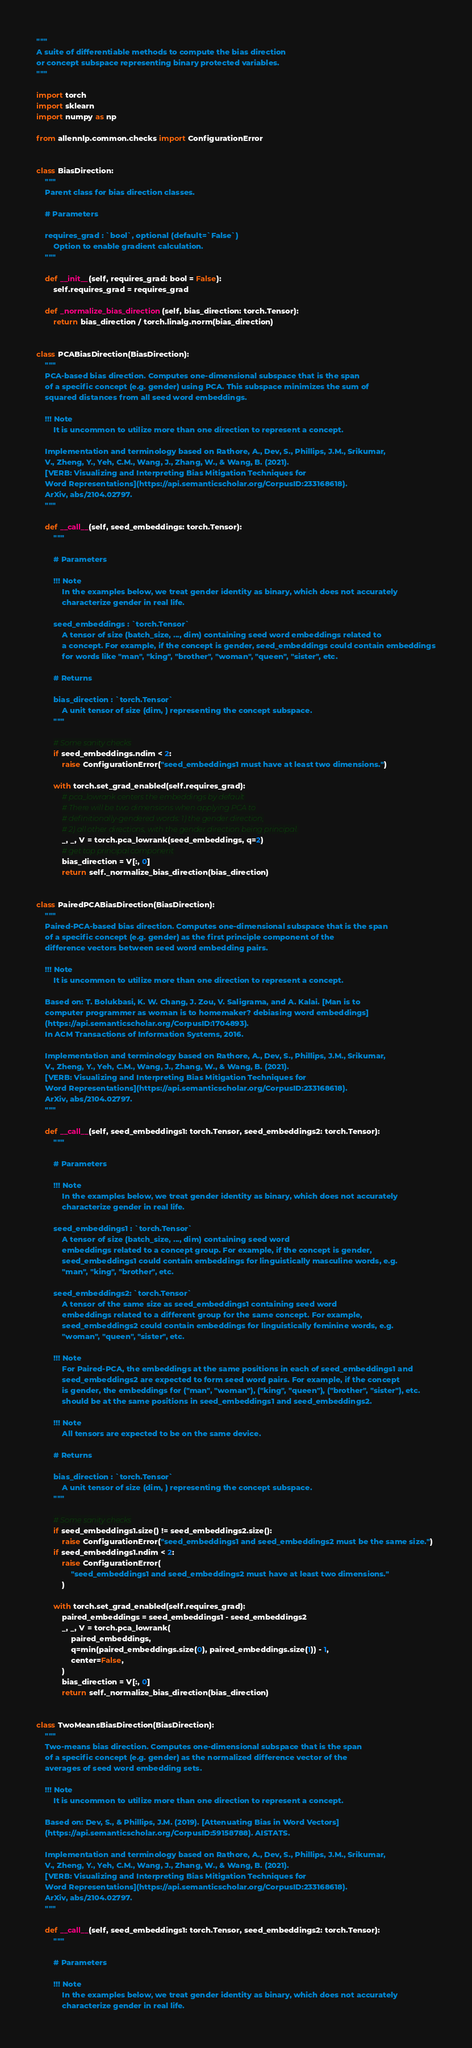<code> <loc_0><loc_0><loc_500><loc_500><_Python_>"""
A suite of differentiable methods to compute the bias direction
or concept subspace representing binary protected variables.
"""

import torch
import sklearn
import numpy as np

from allennlp.common.checks import ConfigurationError


class BiasDirection:
    """
    Parent class for bias direction classes.

    # Parameters

    requires_grad : `bool`, optional (default=`False`)
        Option to enable gradient calculation.
    """

    def __init__(self, requires_grad: bool = False):
        self.requires_grad = requires_grad

    def _normalize_bias_direction(self, bias_direction: torch.Tensor):
        return bias_direction / torch.linalg.norm(bias_direction)


class PCABiasDirection(BiasDirection):
    """
    PCA-based bias direction. Computes one-dimensional subspace that is the span
    of a specific concept (e.g. gender) using PCA. This subspace minimizes the sum of
    squared distances from all seed word embeddings.

    !!! Note
        It is uncommon to utilize more than one direction to represent a concept.

    Implementation and terminology based on Rathore, A., Dev, S., Phillips, J.M., Srikumar,
    V., Zheng, Y., Yeh, C.M., Wang, J., Zhang, W., & Wang, B. (2021).
    [VERB: Visualizing and Interpreting Bias Mitigation Techniques for
    Word Representations](https://api.semanticscholar.org/CorpusID:233168618).
    ArXiv, abs/2104.02797.
    """

    def __call__(self, seed_embeddings: torch.Tensor):
        """

        # Parameters

        !!! Note
            In the examples below, we treat gender identity as binary, which does not accurately
            characterize gender in real life.

        seed_embeddings : `torch.Tensor`
            A tensor of size (batch_size, ..., dim) containing seed word embeddings related to
            a concept. For example, if the concept is gender, seed_embeddings could contain embeddings
            for words like "man", "king", "brother", "woman", "queen", "sister", etc.

        # Returns

        bias_direction : `torch.Tensor`
            A unit tensor of size (dim, ) representing the concept subspace.
        """

        # Some sanity checks
        if seed_embeddings.ndim < 2:
            raise ConfigurationError("seed_embeddings1 must have at least two dimensions.")

        with torch.set_grad_enabled(self.requires_grad):
            # pca_lowrank centers the embeddings by default
            # There will be two dimensions when applying PCA to
            # definitionally-gendered words: 1) the gender direction,
            # 2) all other directions, with the gender direction being principal.
            _, _, V = torch.pca_lowrank(seed_embeddings, q=2)
            # get top principal component
            bias_direction = V[:, 0]
            return self._normalize_bias_direction(bias_direction)


class PairedPCABiasDirection(BiasDirection):
    """
    Paired-PCA-based bias direction. Computes one-dimensional subspace that is the span
    of a specific concept (e.g. gender) as the first principle component of the
    difference vectors between seed word embedding pairs.

    !!! Note
        It is uncommon to utilize more than one direction to represent a concept.

    Based on: T. Bolukbasi, K. W. Chang, J. Zou, V. Saligrama, and A. Kalai. [Man is to
    computer programmer as woman is to homemaker? debiasing word embeddings]
    (https://api.semanticscholar.org/CorpusID:1704893).
    In ACM Transactions of Information Systems, 2016.

    Implementation and terminology based on Rathore, A., Dev, S., Phillips, J.M., Srikumar,
    V., Zheng, Y., Yeh, C.M., Wang, J., Zhang, W., & Wang, B. (2021).
    [VERB: Visualizing and Interpreting Bias Mitigation Techniques for
    Word Representations](https://api.semanticscholar.org/CorpusID:233168618).
    ArXiv, abs/2104.02797.
    """

    def __call__(self, seed_embeddings1: torch.Tensor, seed_embeddings2: torch.Tensor):
        """

        # Parameters

        !!! Note
            In the examples below, we treat gender identity as binary, which does not accurately
            characterize gender in real life.

        seed_embeddings1 : `torch.Tensor`
            A tensor of size (batch_size, ..., dim) containing seed word
            embeddings related to a concept group. For example, if the concept is gender,
            seed_embeddings1 could contain embeddings for linguistically masculine words, e.g.
            "man", "king", "brother", etc.

        seed_embeddings2: `torch.Tensor`
            A tensor of the same size as seed_embeddings1 containing seed word
            embeddings related to a different group for the same concept. For example,
            seed_embeddings2 could contain embeddings for linguistically feminine words, e.g.
            "woman", "queen", "sister", etc.

        !!! Note
            For Paired-PCA, the embeddings at the same positions in each of seed_embeddings1 and
            seed_embeddings2 are expected to form seed word pairs. For example, if the concept
            is gender, the embeddings for ("man", "woman"), ("king", "queen"), ("brother", "sister"), etc.
            should be at the same positions in seed_embeddings1 and seed_embeddings2.

        !!! Note
            All tensors are expected to be on the same device.

        # Returns

        bias_direction : `torch.Tensor`
            A unit tensor of size (dim, ) representing the concept subspace.
        """

        # Some sanity checks
        if seed_embeddings1.size() != seed_embeddings2.size():
            raise ConfigurationError("seed_embeddings1 and seed_embeddings2 must be the same size.")
        if seed_embeddings1.ndim < 2:
            raise ConfigurationError(
                "seed_embeddings1 and seed_embeddings2 must have at least two dimensions."
            )

        with torch.set_grad_enabled(self.requires_grad):
            paired_embeddings = seed_embeddings1 - seed_embeddings2
            _, _, V = torch.pca_lowrank(
                paired_embeddings,
                q=min(paired_embeddings.size(0), paired_embeddings.size(1)) - 1,
                center=False,
            )
            bias_direction = V[:, 0]
            return self._normalize_bias_direction(bias_direction)


class TwoMeansBiasDirection(BiasDirection):
    """
    Two-means bias direction. Computes one-dimensional subspace that is the span
    of a specific concept (e.g. gender) as the normalized difference vector of the
    averages of seed word embedding sets.

    !!! Note
        It is uncommon to utilize more than one direction to represent a concept.

    Based on: Dev, S., & Phillips, J.M. (2019). [Attenuating Bias in Word Vectors]
    (https://api.semanticscholar.org/CorpusID:59158788). AISTATS.

    Implementation and terminology based on Rathore, A., Dev, S., Phillips, J.M., Srikumar,
    V., Zheng, Y., Yeh, C.M., Wang, J., Zhang, W., & Wang, B. (2021).
    [VERB: Visualizing and Interpreting Bias Mitigation Techniques for
    Word Representations](https://api.semanticscholar.org/CorpusID:233168618).
    ArXiv, abs/2104.02797.
    """

    def __call__(self, seed_embeddings1: torch.Tensor, seed_embeddings2: torch.Tensor):
        """

        # Parameters

        !!! Note
            In the examples below, we treat gender identity as binary, which does not accurately
            characterize gender in real life.
</code> 